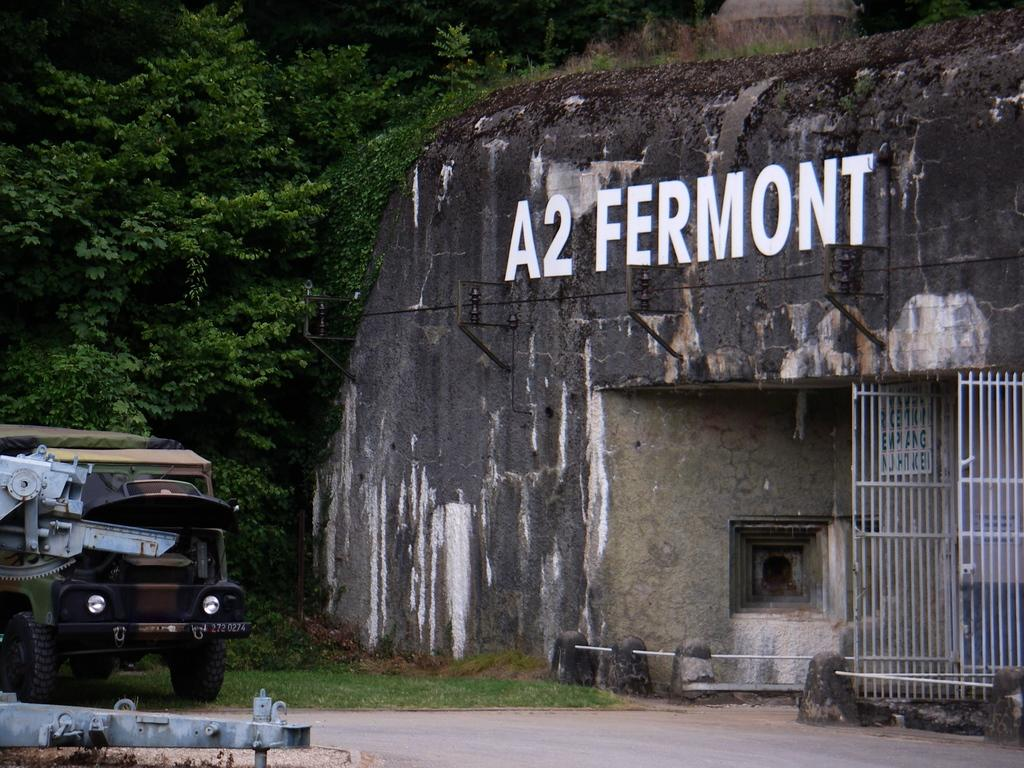What is the main subject of the image? There is a vehicle in the image. What type of environment is depicted in the image? There is grass in the image, suggesting an outdoor setting. What objects can be seen near the vehicle? There are grilles and boards in the image. What is the purpose of the wall in the image? Something is written on the wall, which suggests it might be used for communication or displaying information. What can be seen in the background of the image? There are trees in the background of the image. What type of weather can be seen in the image? The provided facts do not mention any weather conditions in the image. What thrilling activity is taking place in the image? There is no indication of any thrilling activity in the image; it primarily features a vehicle and its surroundings. 